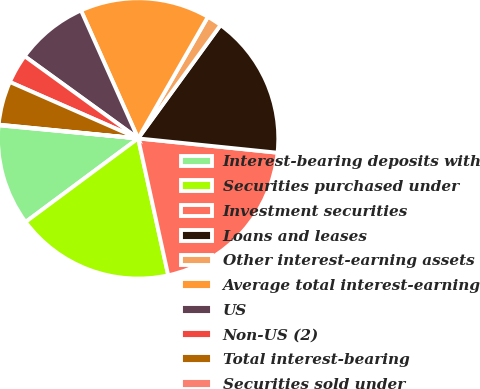Convert chart. <chart><loc_0><loc_0><loc_500><loc_500><pie_chart><fcel>Interest-bearing deposits with<fcel>Securities purchased under<fcel>Investment securities<fcel>Loans and leases<fcel>Other interest-earning assets<fcel>Average total interest-earning<fcel>US<fcel>Non-US (2)<fcel>Total interest-bearing<fcel>Securities sold under<nl><fcel>11.66%<fcel>18.28%<fcel>19.93%<fcel>16.62%<fcel>1.72%<fcel>14.97%<fcel>8.34%<fcel>3.38%<fcel>5.03%<fcel>0.07%<nl></chart> 